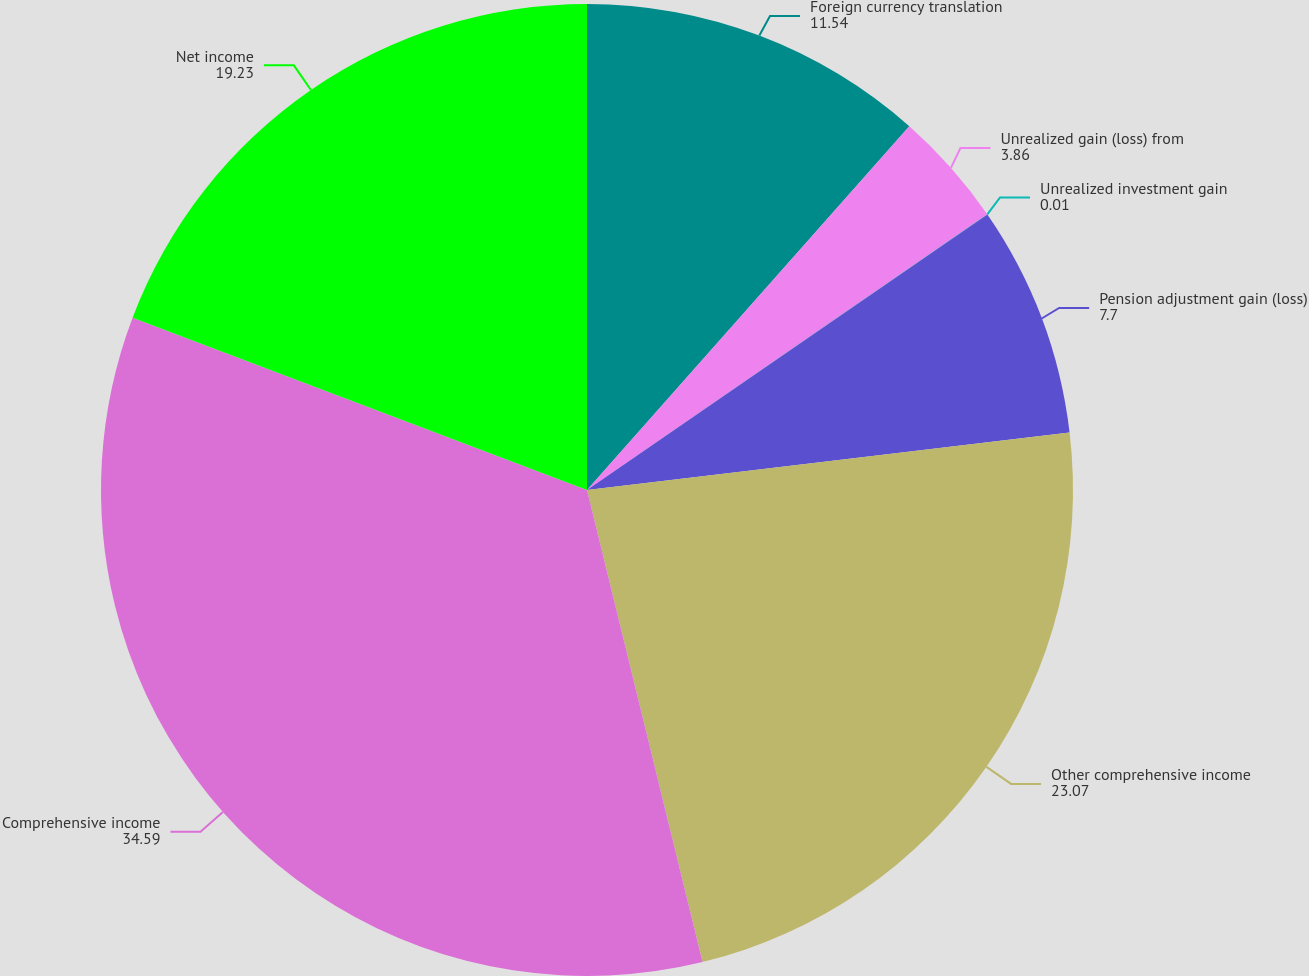<chart> <loc_0><loc_0><loc_500><loc_500><pie_chart><fcel>Foreign currency translation<fcel>Unrealized gain (loss) from<fcel>Unrealized investment gain<fcel>Pension adjustment gain (loss)<fcel>Other comprehensive income<fcel>Comprehensive income<fcel>Net income<nl><fcel>11.54%<fcel>3.86%<fcel>0.01%<fcel>7.7%<fcel>23.07%<fcel>34.59%<fcel>19.23%<nl></chart> 